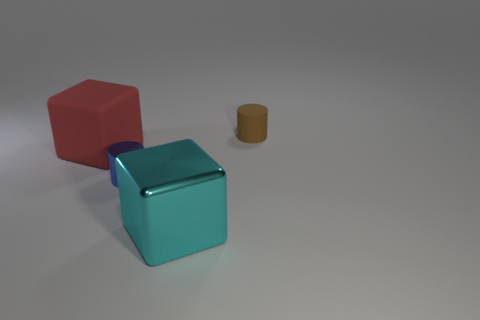Please compare the sizes of the three objects. The teal block appears to be the largest object in terms of volume, followed by the red block which is slightly smaller and less wide. The brown cylinder is the smallest, both in height and diameter. What might be the purpose of these objects if they were used in real life? If these objects were real, they could serve a variety of purposes. The blocks might be used as building toys, educational aids for teaching geometry or color differentiation, or as decorative pieces. The cylinder could be a container, a prop, or another decorative element. 